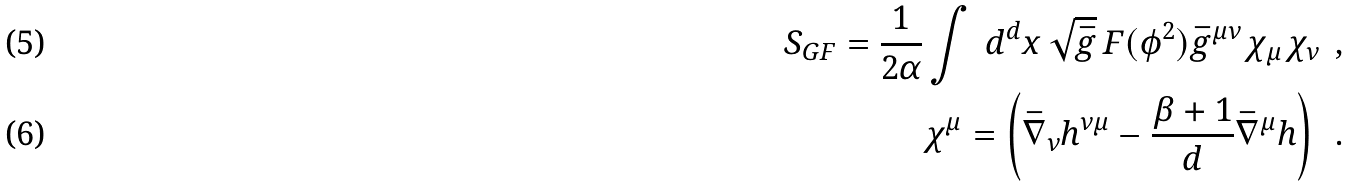Convert formula to latex. <formula><loc_0><loc_0><loc_500><loc_500>S _ { G F } = \frac { 1 } { 2 \alpha } \int \, { d } ^ { d } x \, \sqrt { \bar { g } } \, F ( \phi ^ { 2 } ) \bar { g } ^ { \mu \nu } \, \chi _ { \mu } \, \chi _ { \nu } \, \ , \\ \chi ^ { \mu } = \left ( \bar { \nabla } _ { \nu } h ^ { \nu \mu } - \frac { \beta + 1 } { d } \bar { \nabla } ^ { \mu } h \right ) \, \ .</formula> 